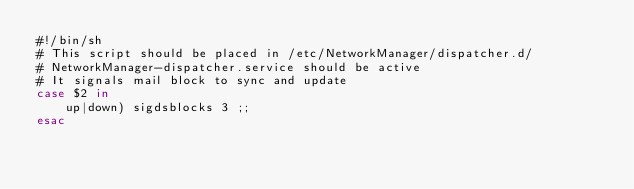<code> <loc_0><loc_0><loc_500><loc_500><_Bash_>#!/bin/sh
# This script should be placed in /etc/NetworkManager/dispatcher.d/
# NetworkManager-dispatcher.service should be active
# It signals mail block to sync and update
case $2 in
    up|down) sigdsblocks 3 ;;
esac
</code> 